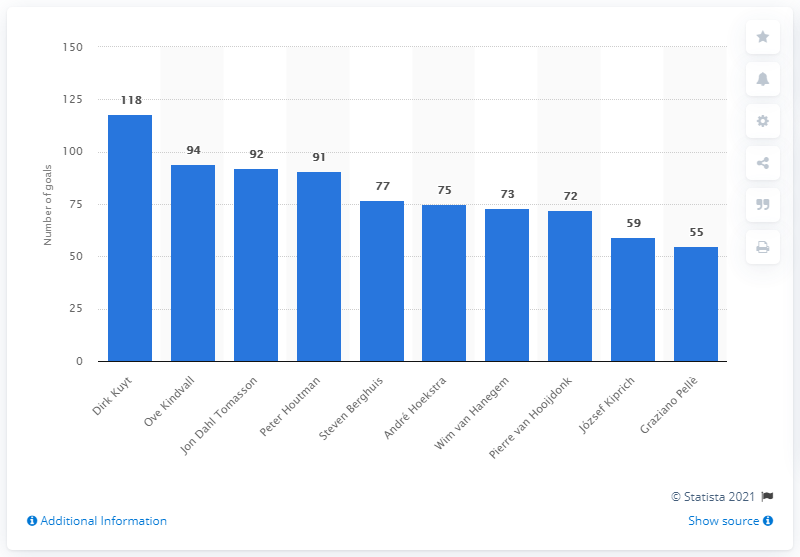Indicate a few pertinent items in this graphic. Dirk Kuyt is currently training the Feyenoord Under 19 team. Ove Kindvall, a player for Feyenoord Rotterdam, scored 94 goals. Ove Kindvall scored 94 goals for Feyenoord Rotterdam. 